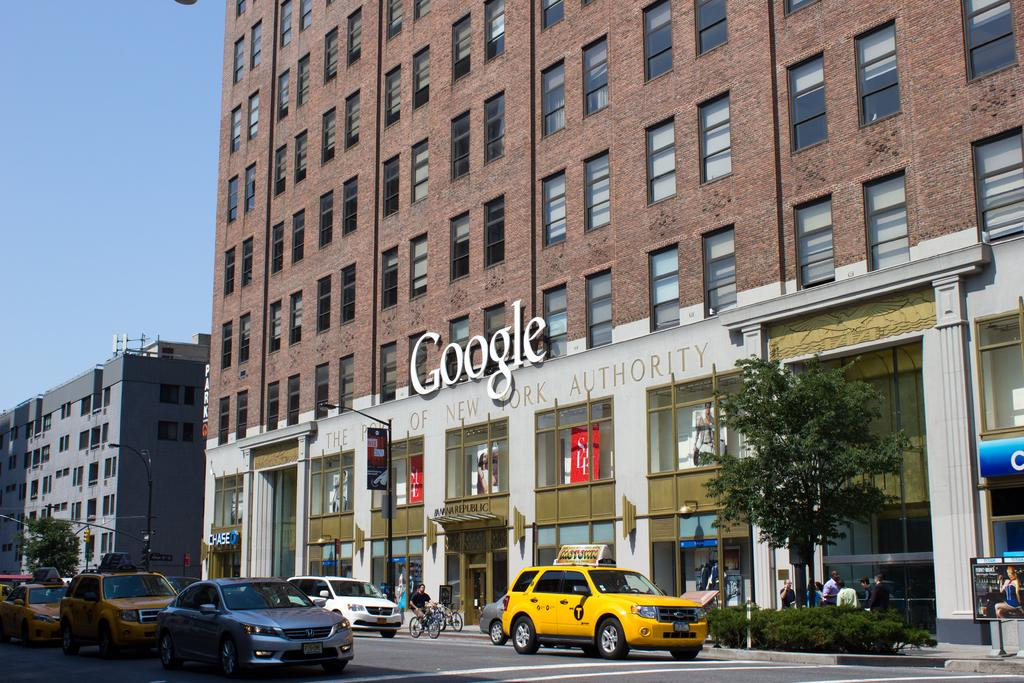Provide a one-sentence caption for the provided image. The outside of a brick building with a large Google sign. 